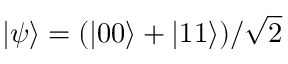Convert formula to latex. <formula><loc_0><loc_0><loc_500><loc_500>| \psi \rangle = ( | 0 0 \rangle + | 1 1 \rangle ) / \sqrt { 2 }</formula> 